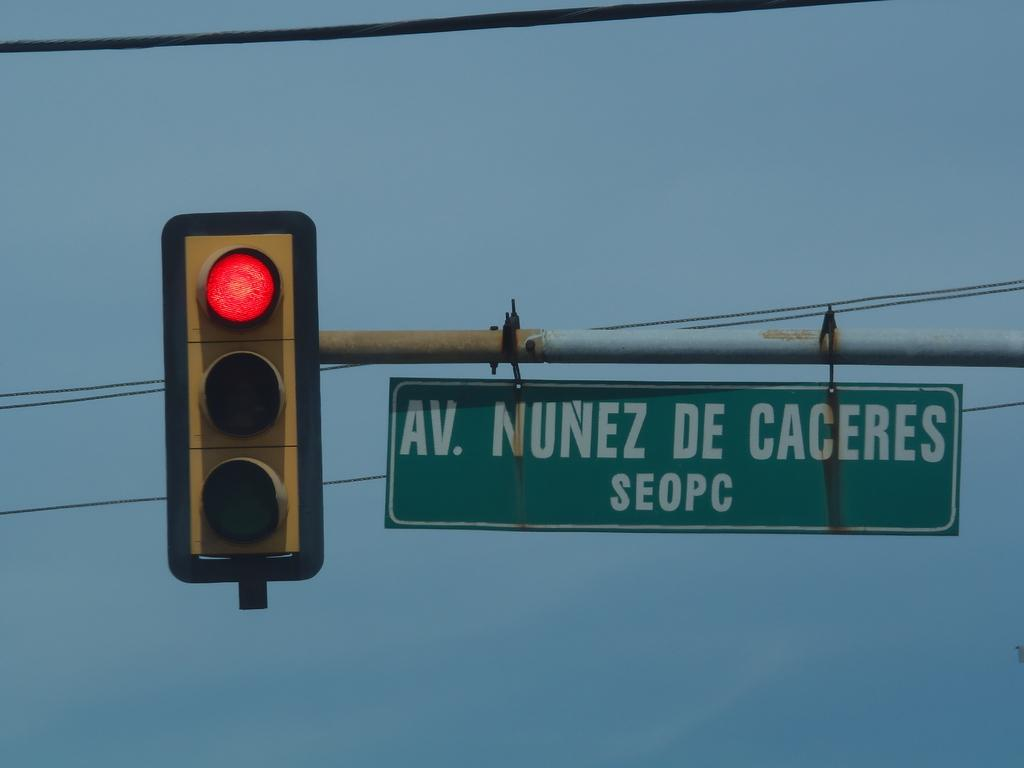<image>
Share a concise interpretation of the image provided. A sign for Av. Nunez De Caceres next to a red traffic light. 